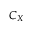<formula> <loc_0><loc_0><loc_500><loc_500>C _ { X }</formula> 